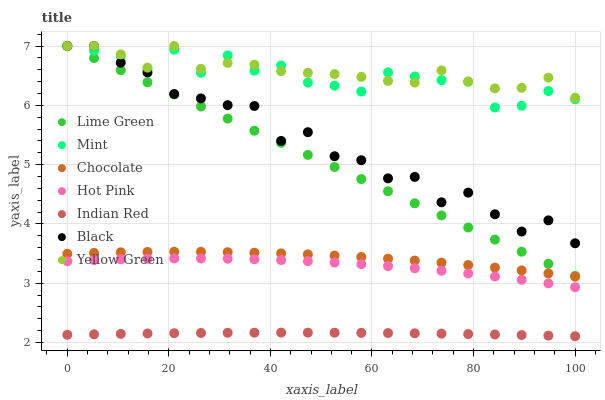Does Indian Red have the minimum area under the curve?
Answer yes or no. Yes. Does Yellow Green have the maximum area under the curve?
Answer yes or no. Yes. Does Lime Green have the minimum area under the curve?
Answer yes or no. No. Does Lime Green have the maximum area under the curve?
Answer yes or no. No. Is Lime Green the smoothest?
Answer yes or no. Yes. Is Black the roughest?
Answer yes or no. Yes. Is Hot Pink the smoothest?
Answer yes or no. No. Is Hot Pink the roughest?
Answer yes or no. No. Does Indian Red have the lowest value?
Answer yes or no. Yes. Does Lime Green have the lowest value?
Answer yes or no. No. Does Mint have the highest value?
Answer yes or no. Yes. Does Hot Pink have the highest value?
Answer yes or no. No. Is Indian Red less than Lime Green?
Answer yes or no. Yes. Is Yellow Green greater than Indian Red?
Answer yes or no. Yes. Does Black intersect Yellow Green?
Answer yes or no. Yes. Is Black less than Yellow Green?
Answer yes or no. No. Is Black greater than Yellow Green?
Answer yes or no. No. Does Indian Red intersect Lime Green?
Answer yes or no. No. 